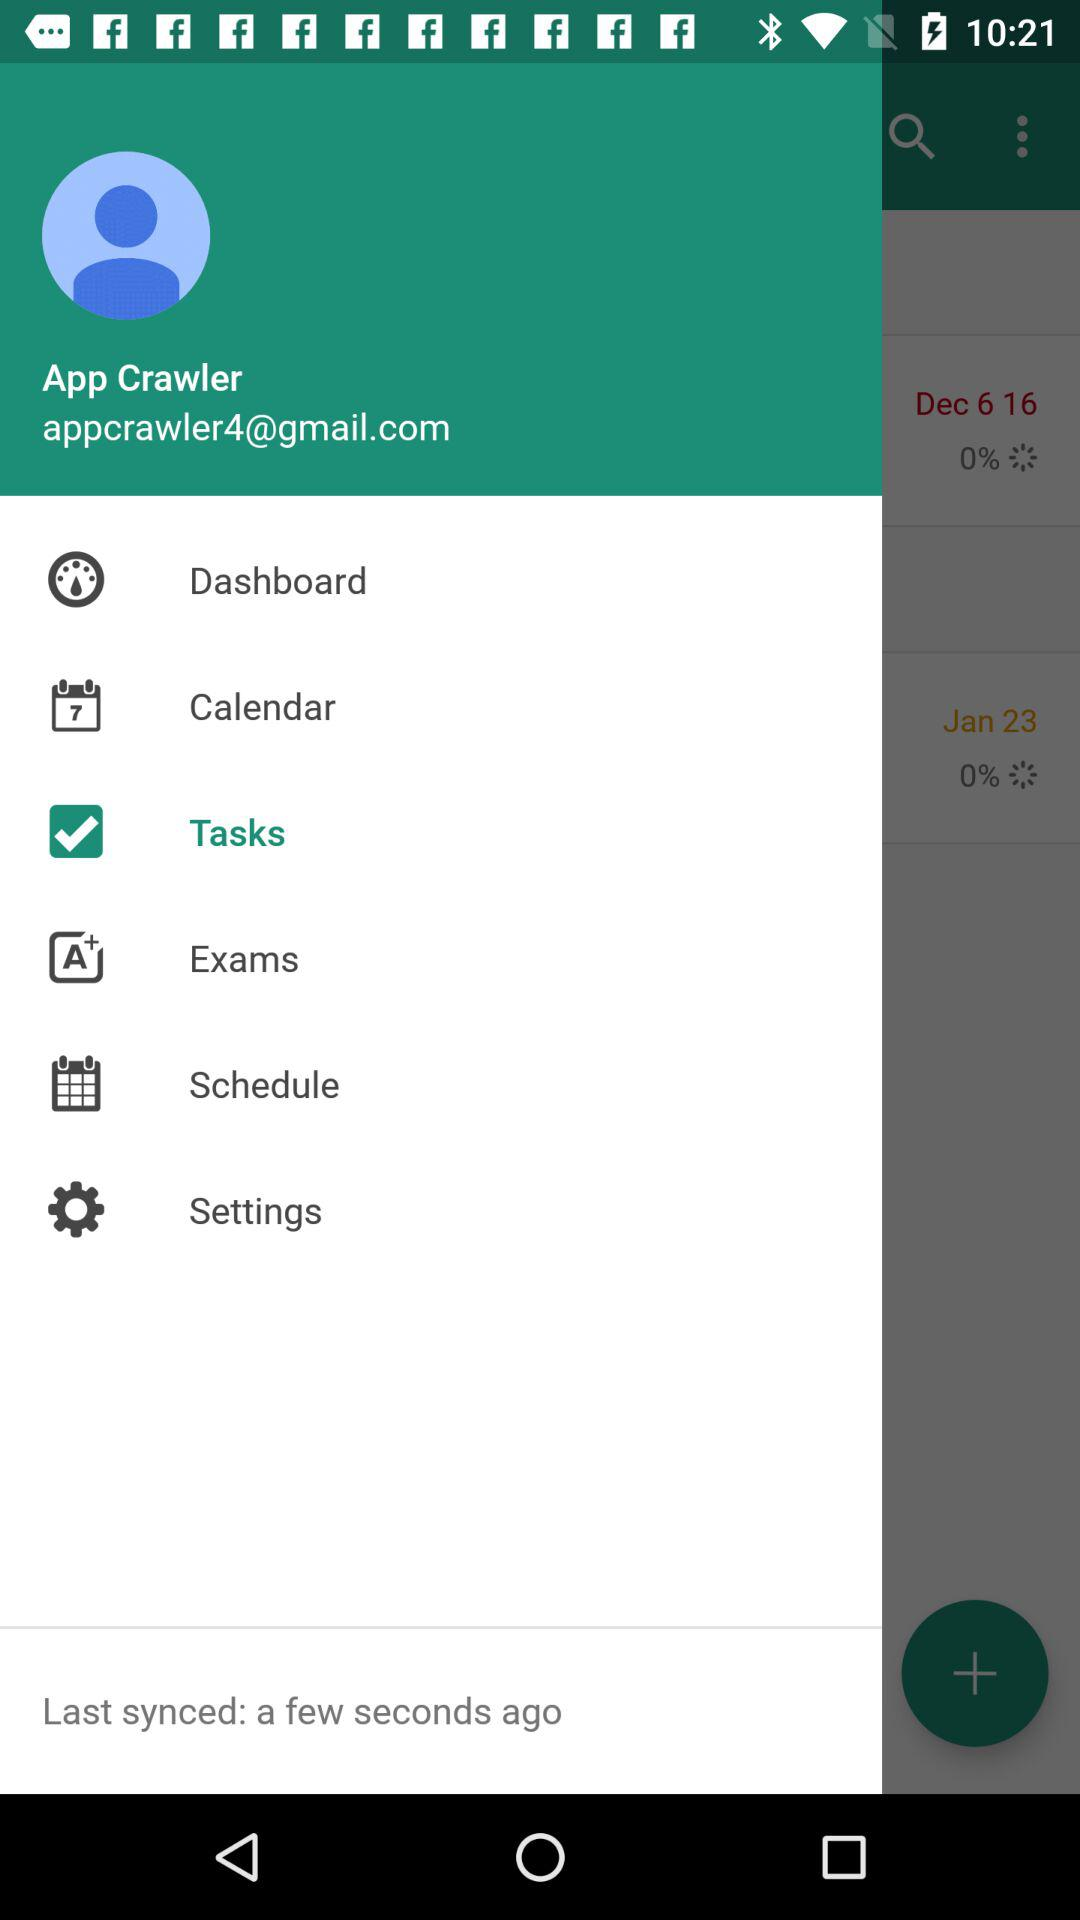When was the last sync done? The last sync was done a few seconds ago. 